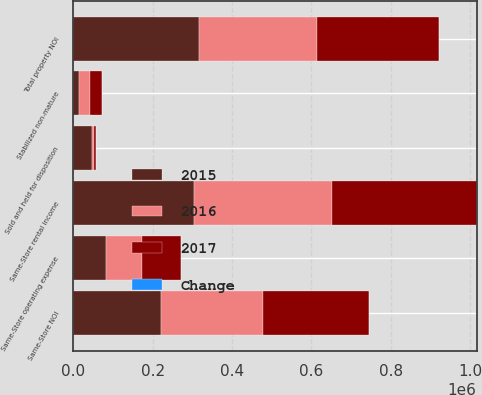Convert chart to OTSL. <chart><loc_0><loc_0><loc_500><loc_500><stacked_bar_chart><ecel><fcel>Same-Store rental income<fcel>Same-Store operating expense<fcel>Same-Store NOI<fcel>Stabilized non-mature<fcel>Sold and held for disposition<fcel>Total property NOI<nl><fcel>2017<fcel>364158<fcel>96589<fcel>267569<fcel>29566<fcel>3373<fcel>306841<nl><fcel>2016<fcel>349425<fcel>92542<fcel>256883<fcel>28312<fcel>5874<fcel>297121<nl><fcel>Change<fcel>4.2<fcel>4.4<fcel>4.2<fcel>4.4<fcel>42.6<fcel>3.3<nl><fcel>2015<fcel>303190<fcel>81438<fcel>221752<fcel>14307<fcel>46574<fcel>317597<nl></chart> 